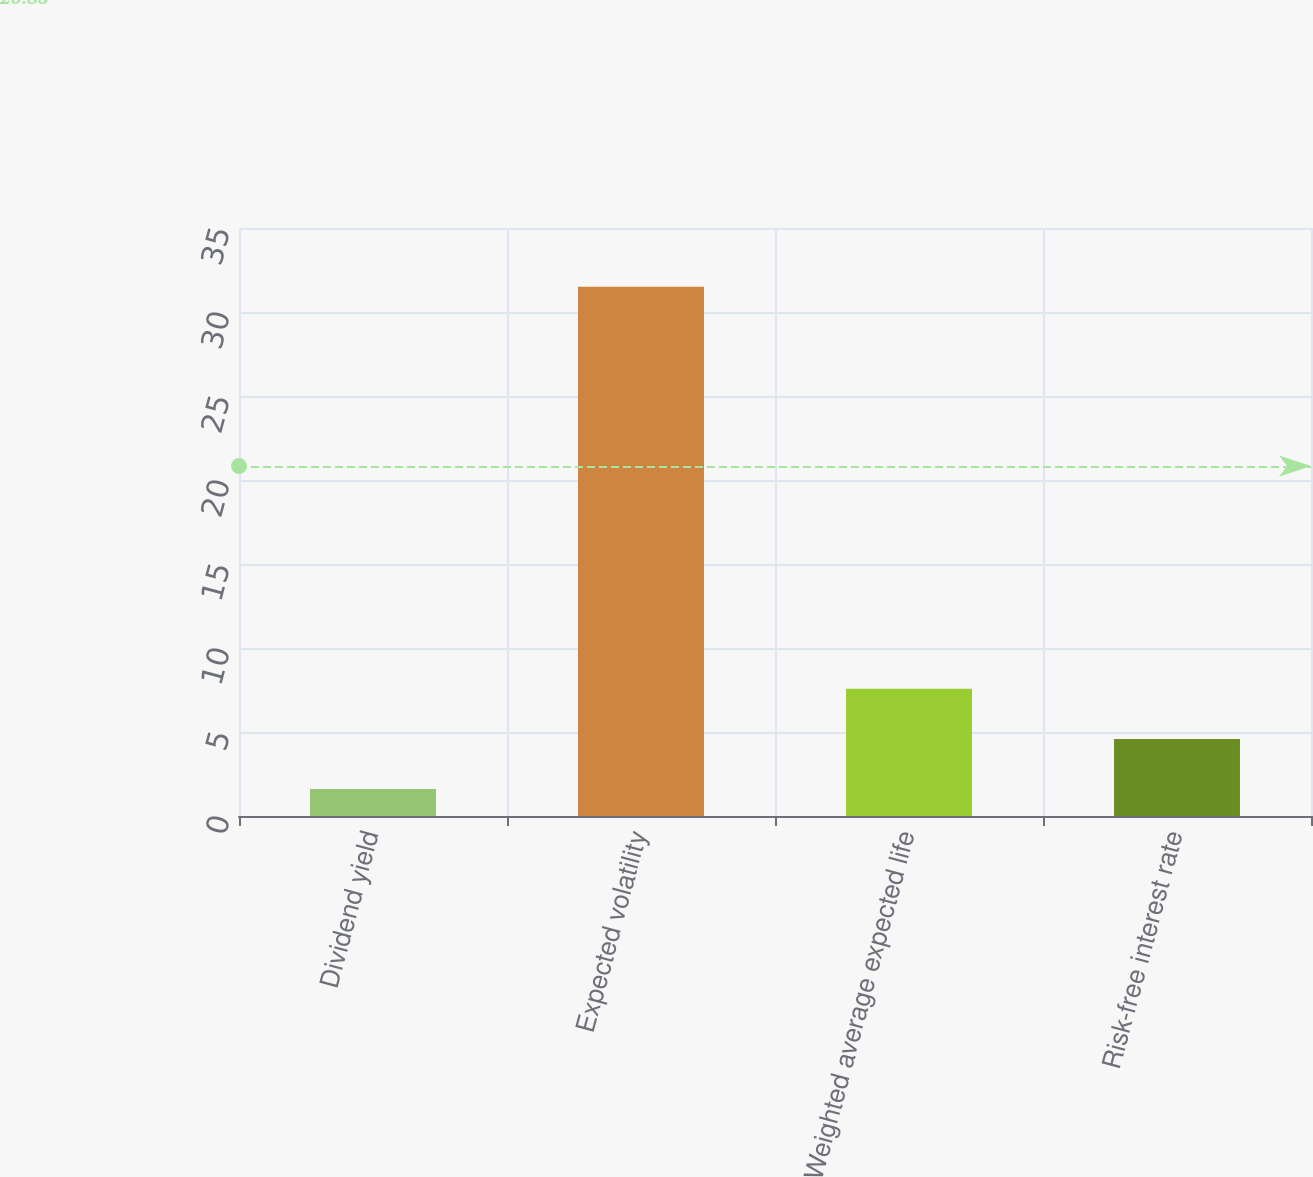Convert chart. <chart><loc_0><loc_0><loc_500><loc_500><bar_chart><fcel>Dividend yield<fcel>Expected volatility<fcel>Weighted average expected life<fcel>Risk-free interest rate<nl><fcel>1.6<fcel>31.5<fcel>7.58<fcel>4.59<nl></chart> 